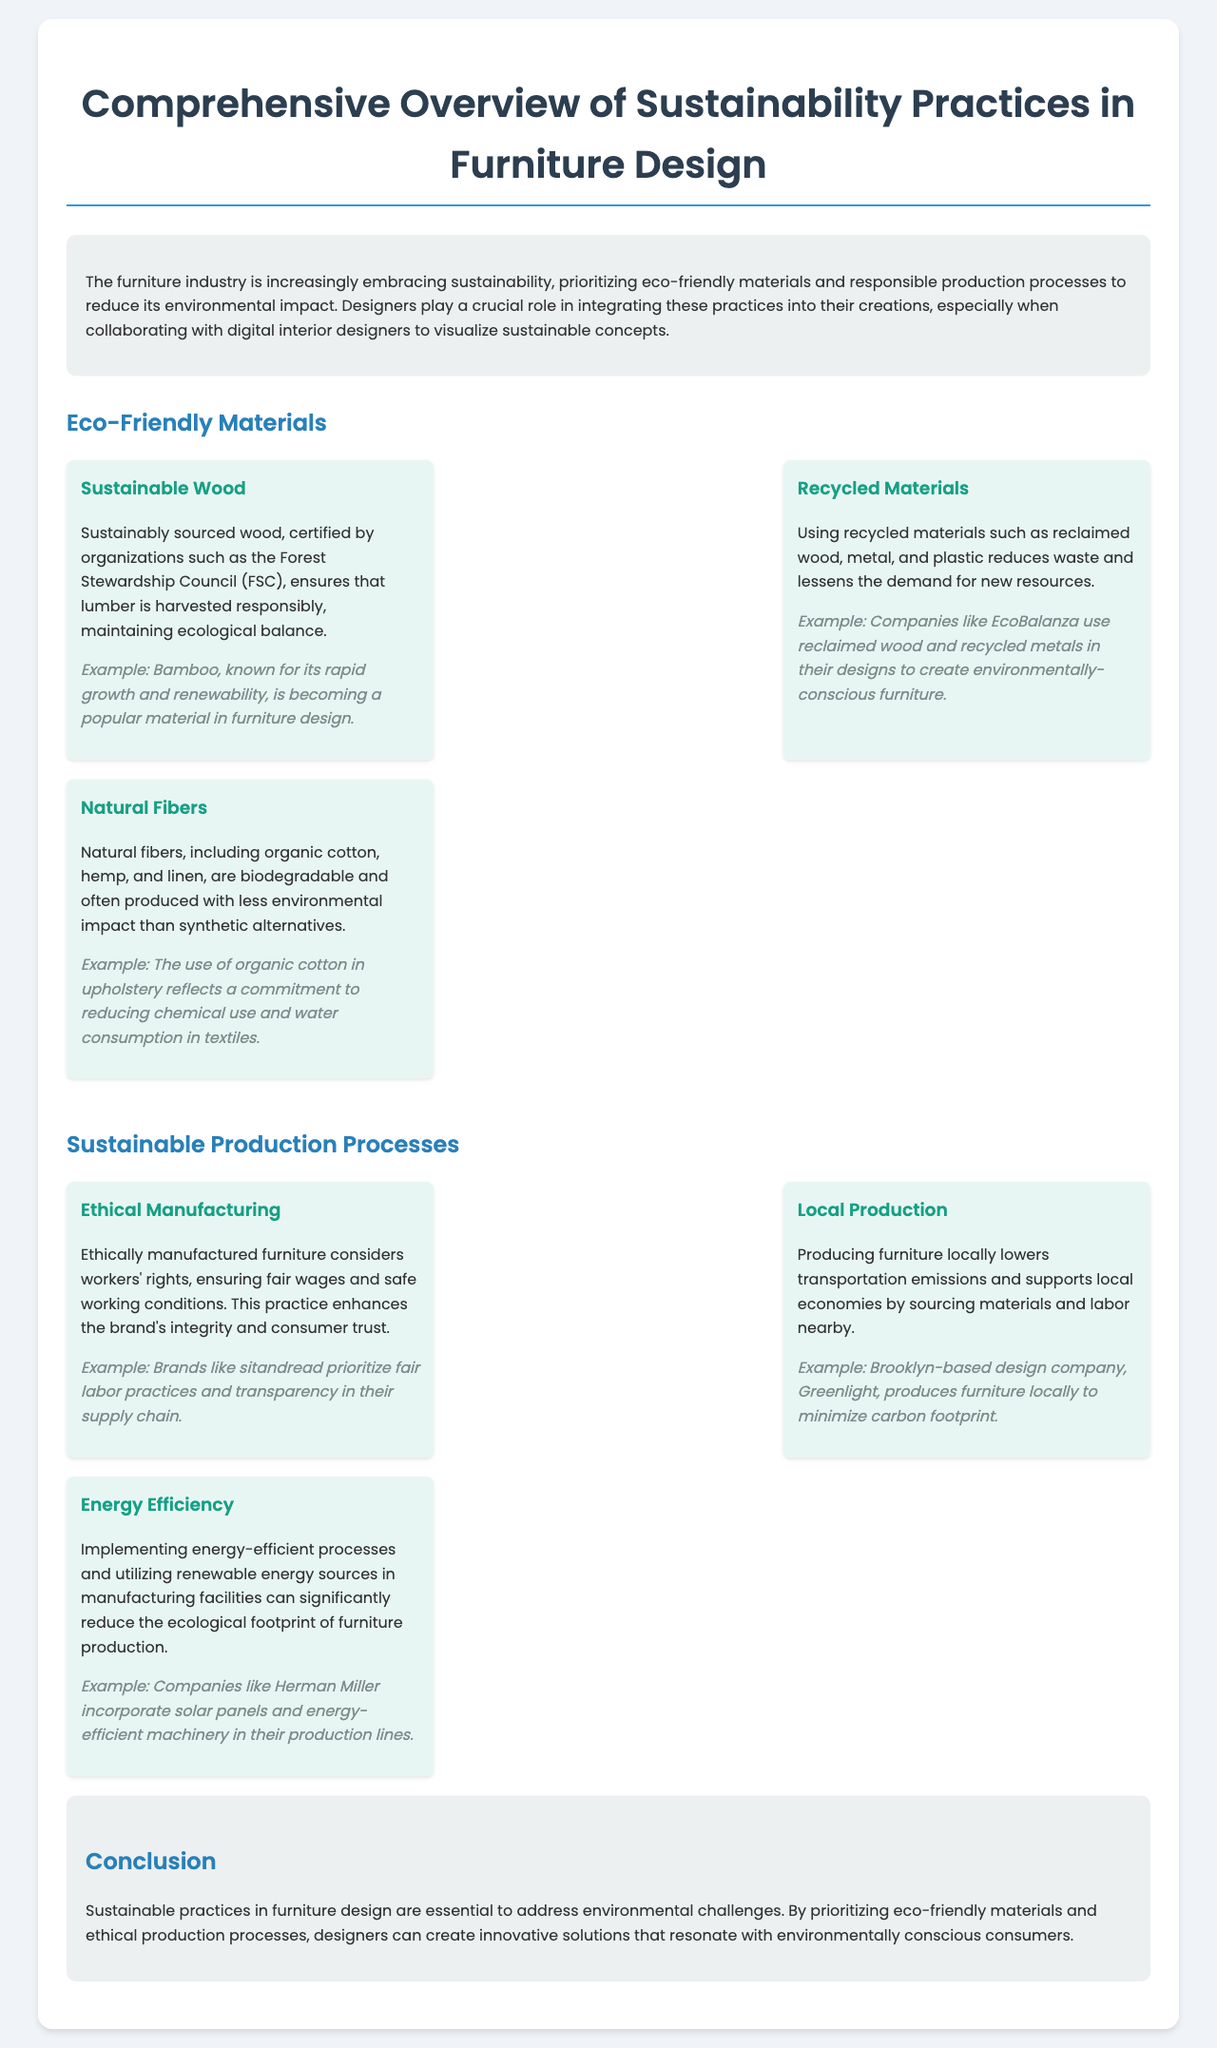What is the title of the report? The title is stated at the top of the document, summarizing the focus on sustainability practices in furniture design.
Answer: Comprehensive Overview of Sustainability Practices in Furniture Design Which organization certifies sustainable wood? The document mentions organizations that certify sustainable wood, specifically noting one by name.
Answer: Forest Stewardship Council What example is given for sustainable wood? An example is provided to illustrate the concept of sustainable wood.
Answer: Bamboo What are two eco-friendly materials mentioned? The document lists various eco-friendly materials and requests two specific examples.
Answer: Sustainable Wood, Recycled Materials What is one principle of ethical manufacturing? The document outlines aspects of ethical manufacturing and asks for a single principle that encapsulates it.
Answer: Fair wages How does local production benefit the environment? The document explains the environmental benefits of producing furniture locally and requests a supporting statement.
Answer: Lowers transportation emissions What does energy efficiency in production refer to? The document discusses energy efficiency and asks for a brief explanation related to that concept.
Answer: Renewable energy sources What is the primary conclusion of the report? The report concludes with a summary of the importance of sustainability in furniture design.
Answer: Essential to address environmental challenges Who is mentioned as a brand that prioritizes ethical manufacturing? A specific brand is provided as an example of ethical manufacturing within the report.
Answer: sitandread What is the benefit of using natural fibers in furniture design? The document highlights the benefits of natural fibers, requesting a concise summary.
Answer: Biodegradable 